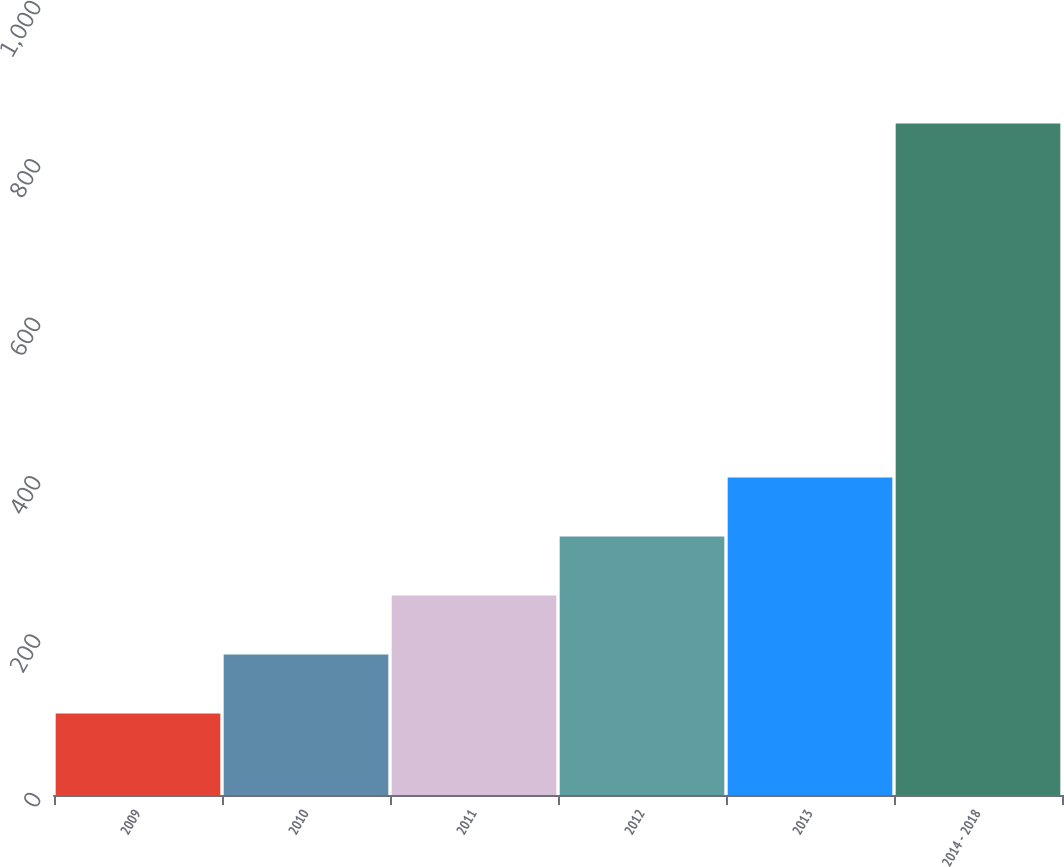<chart> <loc_0><loc_0><loc_500><loc_500><bar_chart><fcel>2009<fcel>2010<fcel>2011<fcel>2012<fcel>2013<fcel>2014 - 2018<nl><fcel>103<fcel>177.5<fcel>252<fcel>326.5<fcel>401<fcel>848<nl></chart> 